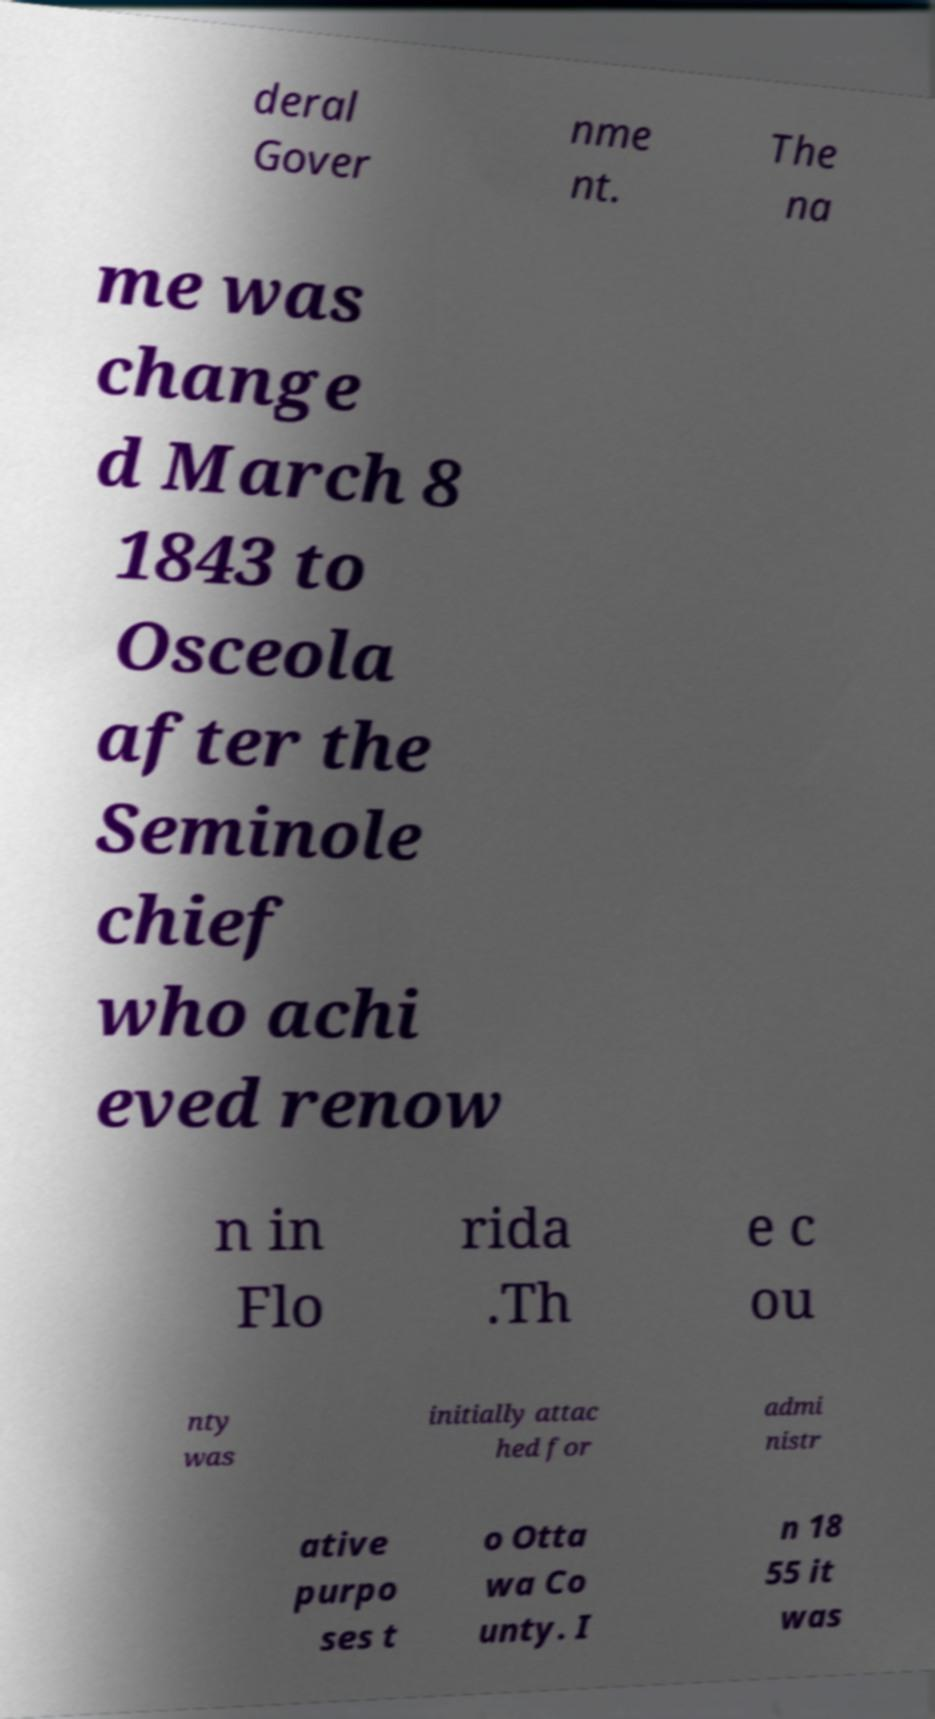There's text embedded in this image that I need extracted. Can you transcribe it verbatim? deral Gover nme nt. The na me was change d March 8 1843 to Osceola after the Seminole chief who achi eved renow n in Flo rida .Th e c ou nty was initially attac hed for admi nistr ative purpo ses t o Otta wa Co unty. I n 18 55 it was 